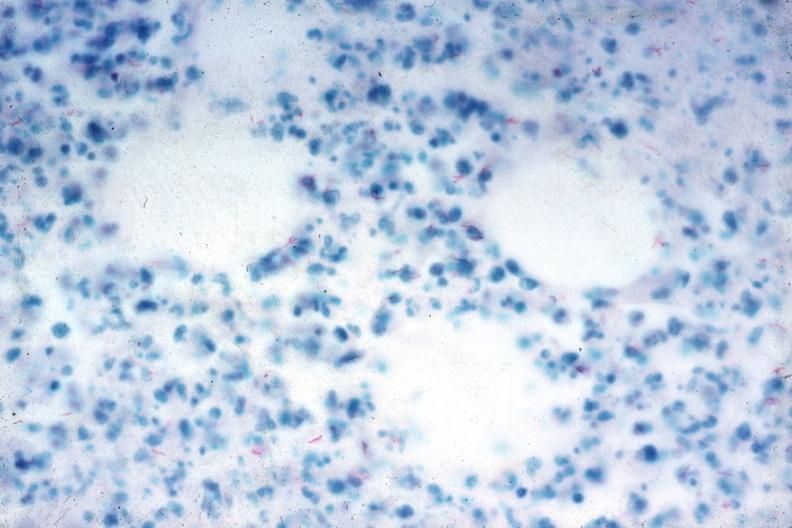s liver with tuberculoid granuloma in glissons present?
Answer the question using a single word or phrase. No 